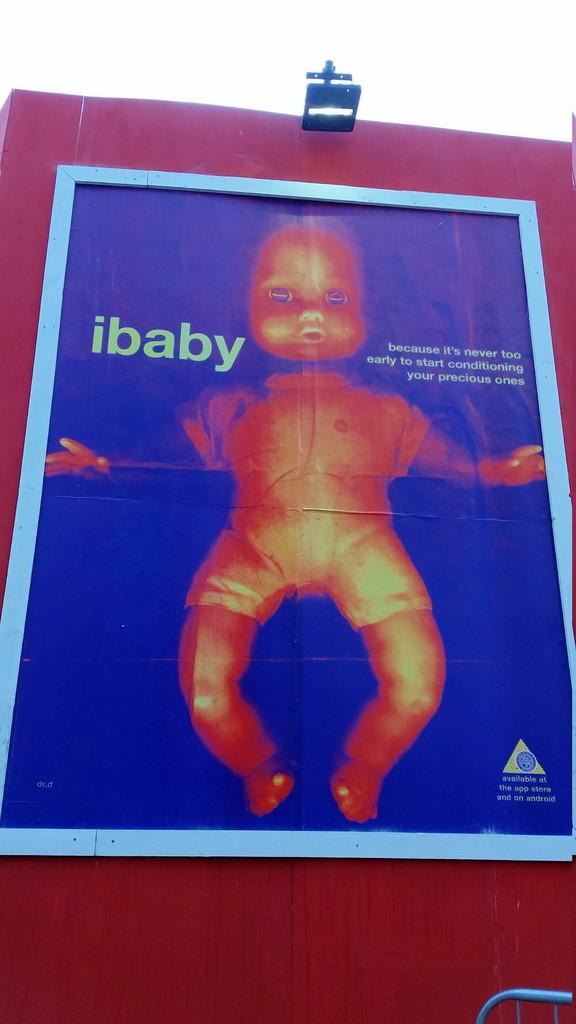What is the main subject of the image? The main subject of the image is a hoarding. What can be seen on the hoarding? The hoarding contains a baby's picture. Is there any lighting feature on the hoarding? Yes, there is a light present at the top of the hoarding. How does the bomb affect the form of the hoarding in the image? There is no bomb present in the image, so its effect on the form of the hoarding cannot be determined. 